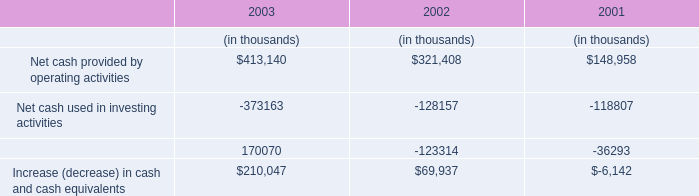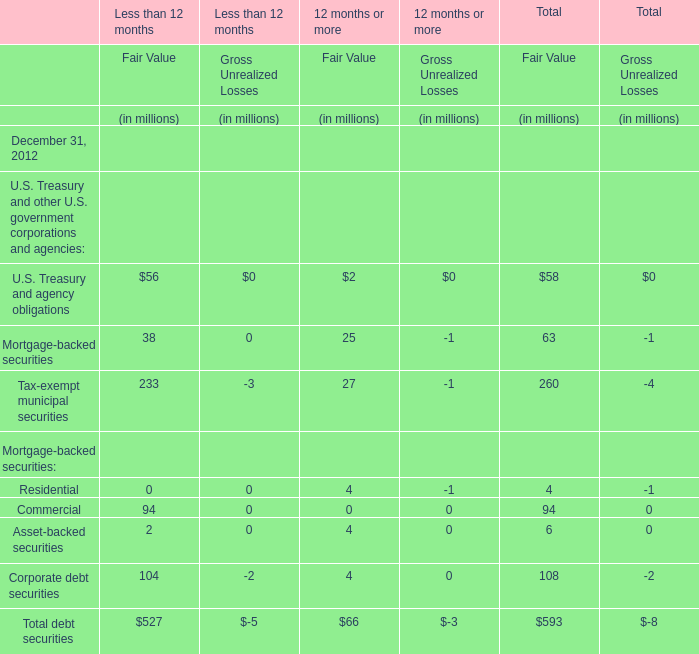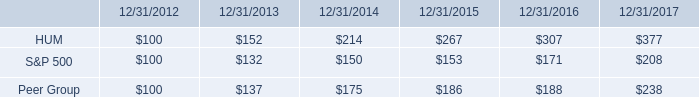What's the sum of all Fair Value that are positive in 2012 for 12 months or more? (in million) 
Computations: (((((2 + 25) + 27) + 4) + 4) + 4)
Answer: 66.0. 